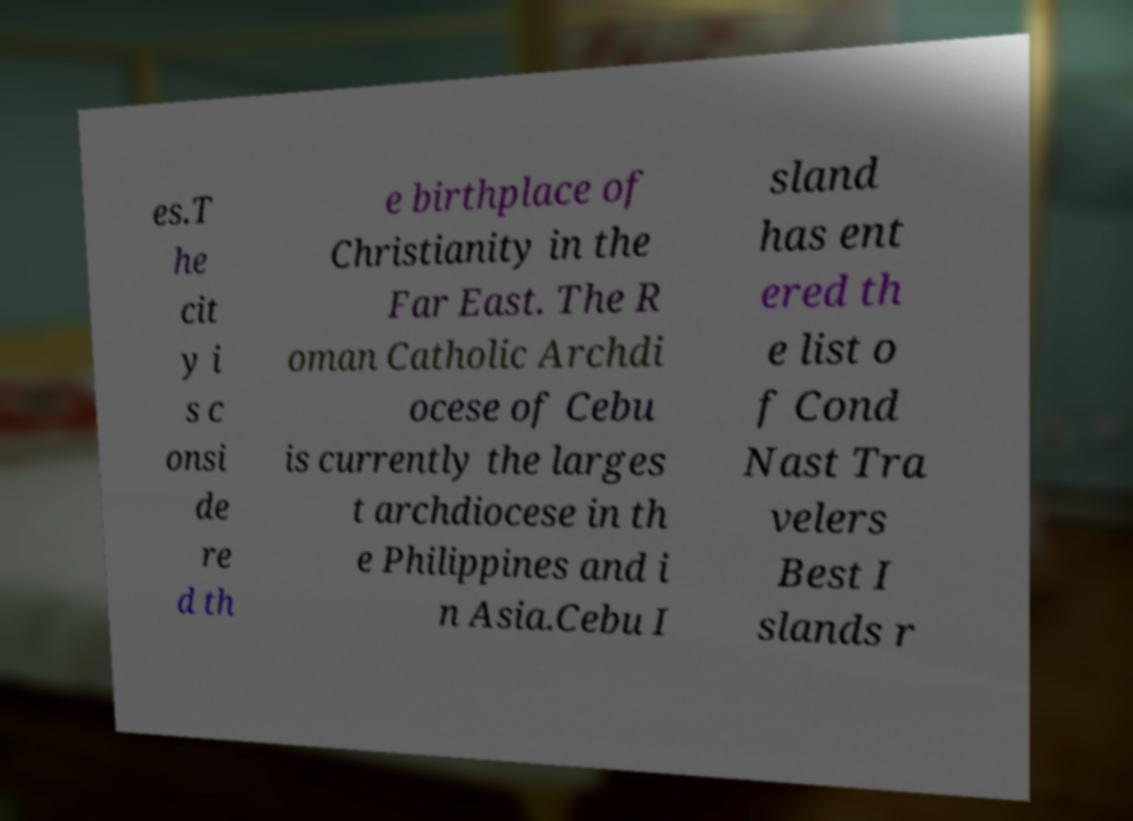Please read and relay the text visible in this image. What does it say? es.T he cit y i s c onsi de re d th e birthplace of Christianity in the Far East. The R oman Catholic Archdi ocese of Cebu is currently the larges t archdiocese in th e Philippines and i n Asia.Cebu I sland has ent ered th e list o f Cond Nast Tra velers Best I slands r 